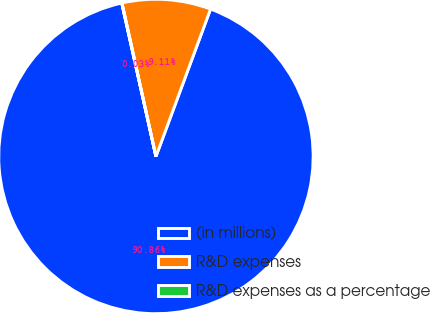Convert chart. <chart><loc_0><loc_0><loc_500><loc_500><pie_chart><fcel>(in millions)<fcel>R&D expenses<fcel>R&D expenses as a percentage<nl><fcel>90.85%<fcel>9.11%<fcel>0.03%<nl></chart> 